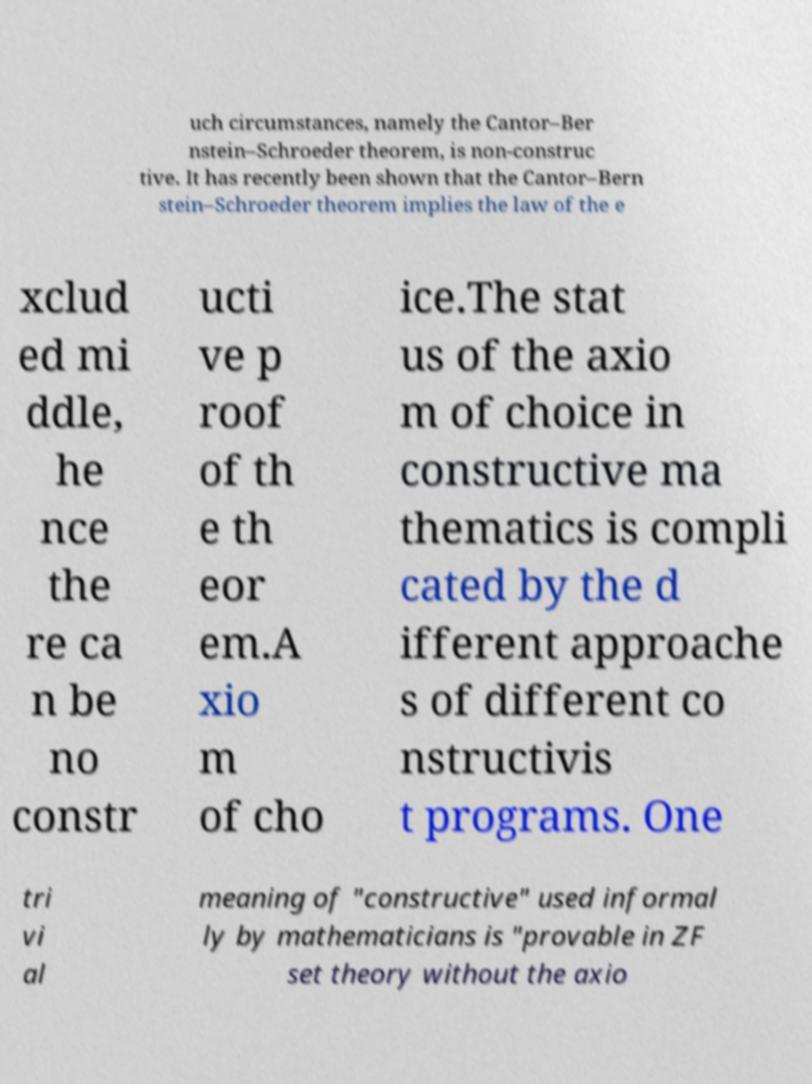What messages or text are displayed in this image? I need them in a readable, typed format. uch circumstances, namely the Cantor–Ber nstein–Schroeder theorem, is non-construc tive. It has recently been shown that the Cantor–Bern stein–Schroeder theorem implies the law of the e xclud ed mi ddle, he nce the re ca n be no constr ucti ve p roof of th e th eor em.A xio m of cho ice.The stat us of the axio m of choice in constructive ma thematics is compli cated by the d ifferent approache s of different co nstructivis t programs. One tri vi al meaning of "constructive" used informal ly by mathematicians is "provable in ZF set theory without the axio 